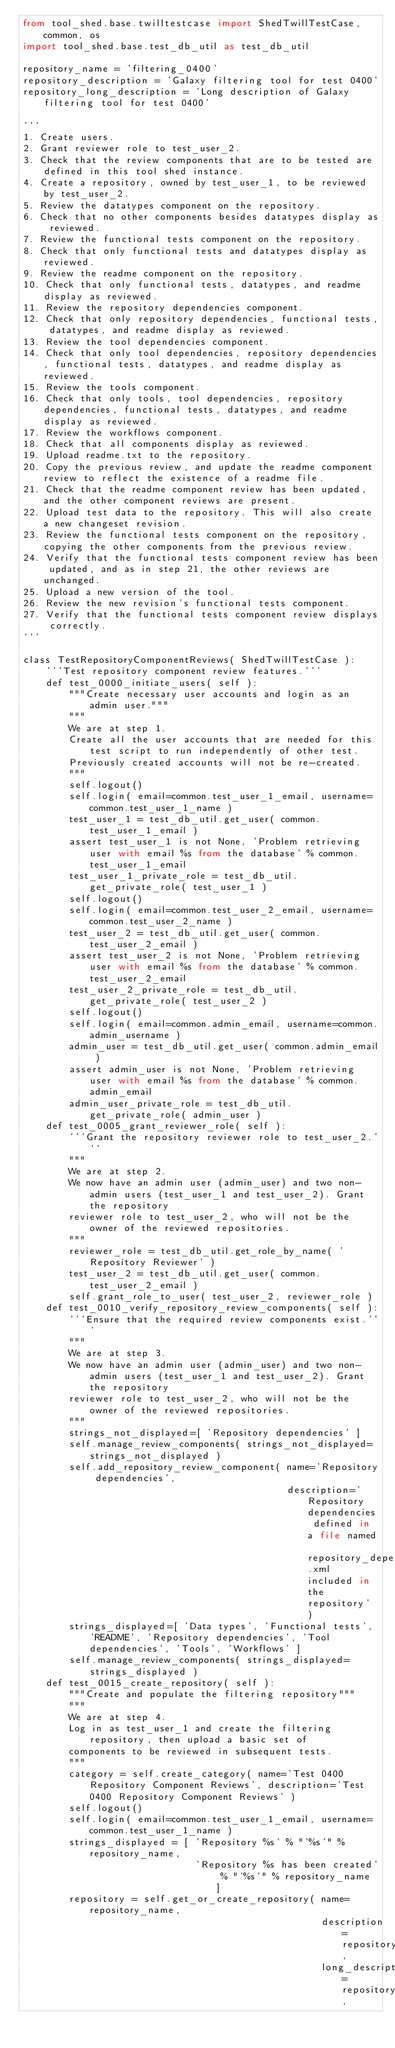Convert code to text. <code><loc_0><loc_0><loc_500><loc_500><_Python_>from tool_shed.base.twilltestcase import ShedTwillTestCase, common, os
import tool_shed.base.test_db_util as test_db_util

repository_name = 'filtering_0400'
repository_description = 'Galaxy filtering tool for test 0400'
repository_long_description = 'Long description of Galaxy filtering tool for test 0400'

'''
1. Create users.
2. Grant reviewer role to test_user_2.
3. Check that the review components that are to be tested are defined in this tool shed instance.
4. Create a repository, owned by test_user_1, to be reviewed by test_user_2.
5. Review the datatypes component on the repository.
6. Check that no other components besides datatypes display as reviewed.
7. Review the functional tests component on the repository.
8. Check that only functional tests and datatypes display as reviewed.
9. Review the readme component on the repository.
10. Check that only functional tests, datatypes, and readme display as reviewed.
11. Review the repository dependencies component.
12. Check that only repository dependencies, functional tests, datatypes, and readme display as reviewed.
13. Review the tool dependencies component.
14. Check that only tool dependencies, repository dependencies, functional tests, datatypes, and readme display as reviewed.
15. Review the tools component.
16. Check that only tools, tool dependencies, repository dependencies, functional tests, datatypes, and readme display as reviewed.
17. Review the workflows component.
18. Check that all components display as reviewed.
19. Upload readme.txt to the repository.
20. Copy the previous review, and update the readme component review to reflect the existence of a readme file.
21. Check that the readme component review has been updated, and the other component reviews are present.
22. Upload test data to the repository. This will also create a new changeset revision.
23. Review the functional tests component on the repository, copying the other components from the previous review.
24. Verify that the functional tests component review has been updated, and as in step 21, the other reviews are unchanged.
25. Upload a new version of the tool.
26. Review the new revision's functional tests component.
27. Verify that the functional tests component review displays correctly.
'''

class TestRepositoryComponentReviews( ShedTwillTestCase ):
    '''Test repository component review features.'''
    def test_0000_initiate_users( self ):
        """Create necessary user accounts and login as an admin user."""
        """
        We are at step 1.
        Create all the user accounts that are needed for this test script to run independently of other test.
        Previously created accounts will not be re-created.
        """
        self.logout()
        self.login( email=common.test_user_1_email, username=common.test_user_1_name )
        test_user_1 = test_db_util.get_user( common.test_user_1_email )
        assert test_user_1 is not None, 'Problem retrieving user with email %s from the database' % common.test_user_1_email
        test_user_1_private_role = test_db_util.get_private_role( test_user_1 )
        self.logout()
        self.login( email=common.test_user_2_email, username=common.test_user_2_name )
        test_user_2 = test_db_util.get_user( common.test_user_2_email )
        assert test_user_2 is not None, 'Problem retrieving user with email %s from the database' % common.test_user_2_email
        test_user_2_private_role = test_db_util.get_private_role( test_user_2 )
        self.logout()
        self.login( email=common.admin_email, username=common.admin_username )
        admin_user = test_db_util.get_user( common.admin_email )
        assert admin_user is not None, 'Problem retrieving user with email %s from the database' % common.admin_email
        admin_user_private_role = test_db_util.get_private_role( admin_user )
    def test_0005_grant_reviewer_role( self ):
        '''Grant the repository reviewer role to test_user_2.'''
        """
        We are at step 2.
        We now have an admin user (admin_user) and two non-admin users (test_user_1 and test_user_2). Grant the repository 
        reviewer role to test_user_2, who will not be the owner of the reviewed repositories.
        """
        reviewer_role = test_db_util.get_role_by_name( 'Repository Reviewer' )
        test_user_2 = test_db_util.get_user( common.test_user_2_email )
        self.grant_role_to_user( test_user_2, reviewer_role )
    def test_0010_verify_repository_review_components( self ):
        '''Ensure that the required review components exist.'''
        """
        We are at step 3.
        We now have an admin user (admin_user) and two non-admin users (test_user_1 and test_user_2). Grant the repository 
        reviewer role to test_user_2, who will not be the owner of the reviewed repositories.
        """
        strings_not_displayed=[ 'Repository dependencies' ]
        self.manage_review_components( strings_not_displayed=strings_not_displayed )
        self.add_repository_review_component( name='Repository dependencies', 
                                              description='Repository dependencies defined in a file named repository_dependencies.xml included in the repository' )
        strings_displayed=[ 'Data types', 'Functional tests', 'README', 'Repository dependencies', 'Tool dependencies', 'Tools', 'Workflows' ]
        self.manage_review_components( strings_displayed=strings_displayed )
    def test_0015_create_repository( self ):
        """Create and populate the filtering repository"""
        """
        We are at step 4.
        Log in as test_user_1 and create the filtering repository, then upload a basic set of 
        components to be reviewed in subsequent tests.
        """
        category = self.create_category( name='Test 0400 Repository Component Reviews', description='Test 0400 Repository Component Reviews' )
        self.logout()
        self.login( email=common.test_user_1_email, username=common.test_user_1_name )
        strings_displayed = [ 'Repository %s' % "'%s'" % repository_name, 
                              'Repository %s has been created' % "'%s'" % repository_name ]
        repository = self.get_or_create_repository( name=repository_name, 
                                                    description=repository_description, 
                                                    long_description=repository_long_description, </code> 